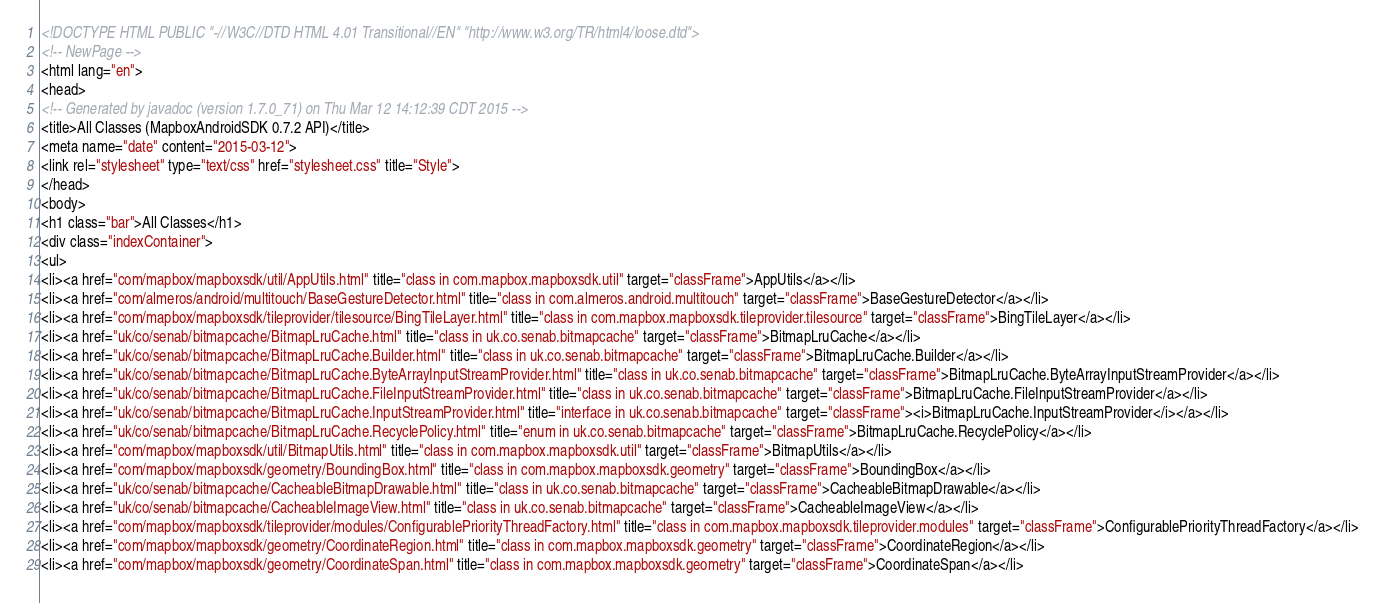Convert code to text. <code><loc_0><loc_0><loc_500><loc_500><_HTML_><!DOCTYPE HTML PUBLIC "-//W3C//DTD HTML 4.01 Transitional//EN" "http://www.w3.org/TR/html4/loose.dtd">
<!-- NewPage -->
<html lang="en">
<head>
<!-- Generated by javadoc (version 1.7.0_71) on Thu Mar 12 14:12:39 CDT 2015 -->
<title>All Classes (MapboxAndroidSDK 0.7.2 API)</title>
<meta name="date" content="2015-03-12">
<link rel="stylesheet" type="text/css" href="stylesheet.css" title="Style">
</head>
<body>
<h1 class="bar">All Classes</h1>
<div class="indexContainer">
<ul>
<li><a href="com/mapbox/mapboxsdk/util/AppUtils.html" title="class in com.mapbox.mapboxsdk.util" target="classFrame">AppUtils</a></li>
<li><a href="com/almeros/android/multitouch/BaseGestureDetector.html" title="class in com.almeros.android.multitouch" target="classFrame">BaseGestureDetector</a></li>
<li><a href="com/mapbox/mapboxsdk/tileprovider/tilesource/BingTileLayer.html" title="class in com.mapbox.mapboxsdk.tileprovider.tilesource" target="classFrame">BingTileLayer</a></li>
<li><a href="uk/co/senab/bitmapcache/BitmapLruCache.html" title="class in uk.co.senab.bitmapcache" target="classFrame">BitmapLruCache</a></li>
<li><a href="uk/co/senab/bitmapcache/BitmapLruCache.Builder.html" title="class in uk.co.senab.bitmapcache" target="classFrame">BitmapLruCache.Builder</a></li>
<li><a href="uk/co/senab/bitmapcache/BitmapLruCache.ByteArrayInputStreamProvider.html" title="class in uk.co.senab.bitmapcache" target="classFrame">BitmapLruCache.ByteArrayInputStreamProvider</a></li>
<li><a href="uk/co/senab/bitmapcache/BitmapLruCache.FileInputStreamProvider.html" title="class in uk.co.senab.bitmapcache" target="classFrame">BitmapLruCache.FileInputStreamProvider</a></li>
<li><a href="uk/co/senab/bitmapcache/BitmapLruCache.InputStreamProvider.html" title="interface in uk.co.senab.bitmapcache" target="classFrame"><i>BitmapLruCache.InputStreamProvider</i></a></li>
<li><a href="uk/co/senab/bitmapcache/BitmapLruCache.RecyclePolicy.html" title="enum in uk.co.senab.bitmapcache" target="classFrame">BitmapLruCache.RecyclePolicy</a></li>
<li><a href="com/mapbox/mapboxsdk/util/BitmapUtils.html" title="class in com.mapbox.mapboxsdk.util" target="classFrame">BitmapUtils</a></li>
<li><a href="com/mapbox/mapboxsdk/geometry/BoundingBox.html" title="class in com.mapbox.mapboxsdk.geometry" target="classFrame">BoundingBox</a></li>
<li><a href="uk/co/senab/bitmapcache/CacheableBitmapDrawable.html" title="class in uk.co.senab.bitmapcache" target="classFrame">CacheableBitmapDrawable</a></li>
<li><a href="uk/co/senab/bitmapcache/CacheableImageView.html" title="class in uk.co.senab.bitmapcache" target="classFrame">CacheableImageView</a></li>
<li><a href="com/mapbox/mapboxsdk/tileprovider/modules/ConfigurablePriorityThreadFactory.html" title="class in com.mapbox.mapboxsdk.tileprovider.modules" target="classFrame">ConfigurablePriorityThreadFactory</a></li>
<li><a href="com/mapbox/mapboxsdk/geometry/CoordinateRegion.html" title="class in com.mapbox.mapboxsdk.geometry" target="classFrame">CoordinateRegion</a></li>
<li><a href="com/mapbox/mapboxsdk/geometry/CoordinateSpan.html" title="class in com.mapbox.mapboxsdk.geometry" target="classFrame">CoordinateSpan</a></li></code> 